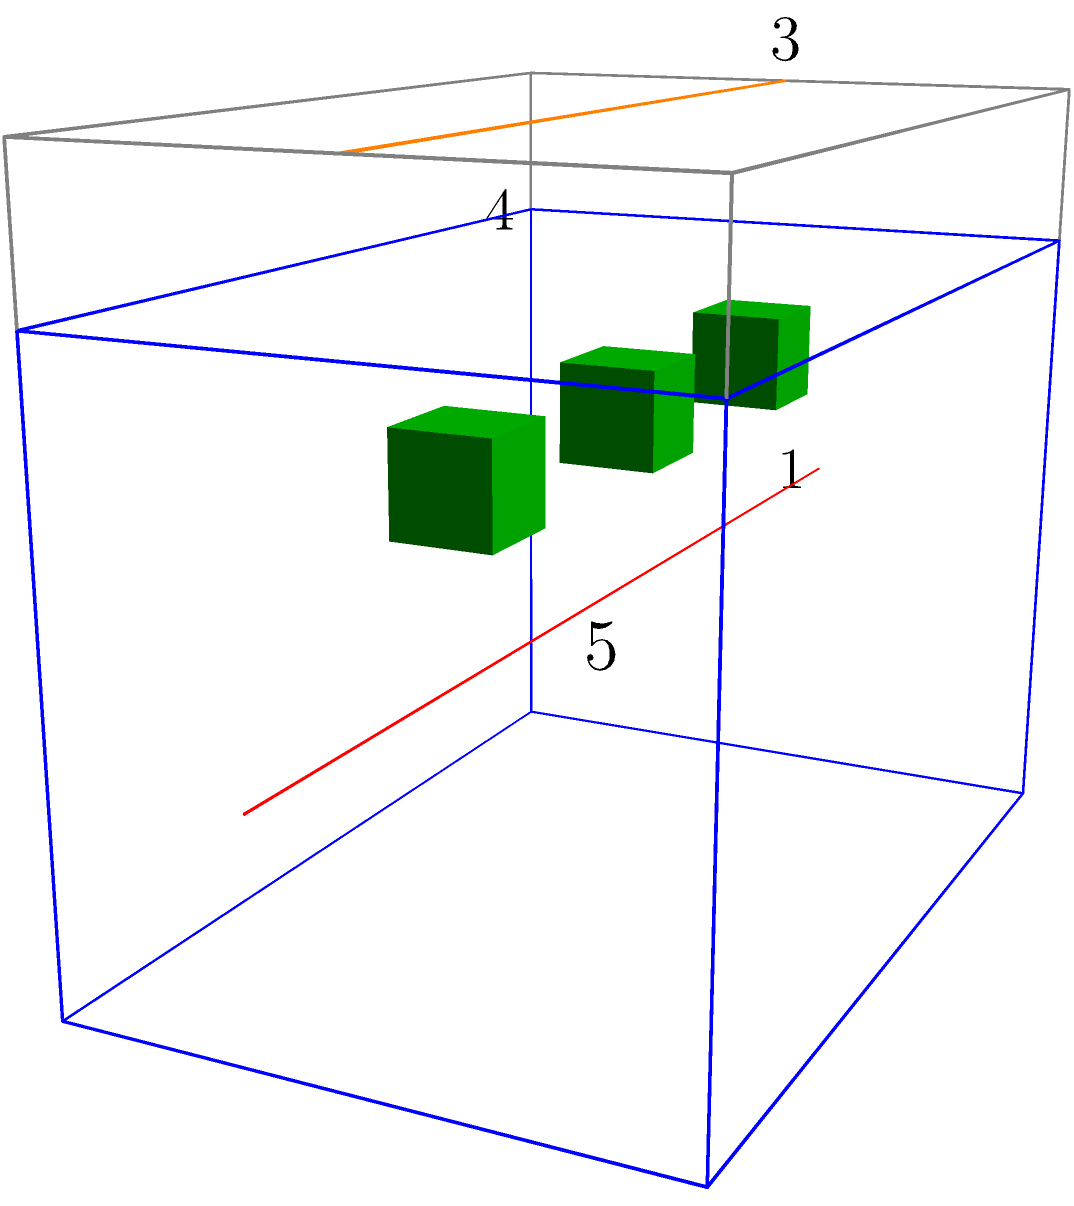In assembling a racing engine, which component labeled in the diagram should be installed first to ensure proper alignment and function of the other parts? To assemble a racing engine correctly, we need to follow a specific order:

1. The crankshaft (labeled 1) is typically the first major component installed in the engine block. It forms the foundation for the engine's rotating assembly.

2. The pistons (labeled 2) are connected to the crankshaft via connecting rods, but they can't be installed until the crankshaft is in place.

3. The camshaft (labeled 3) is usually installed after the crankshaft and before the cylinder head, as it often sits in the engine block.

4. The cylinder head (labeled 4) is one of the last major components to be installed, as it caps off the cylinders and contains the valvetrain.

5. The engine block (labeled 5) is not installed, as it's the base component that houses all other parts.

Therefore, the crankshaft (1) should be installed first to ensure proper alignment and function of the other parts. It's the backbone of the engine, and its correct installation is crucial for the engine's performance and longevity.
Answer: Crankshaft (1) 